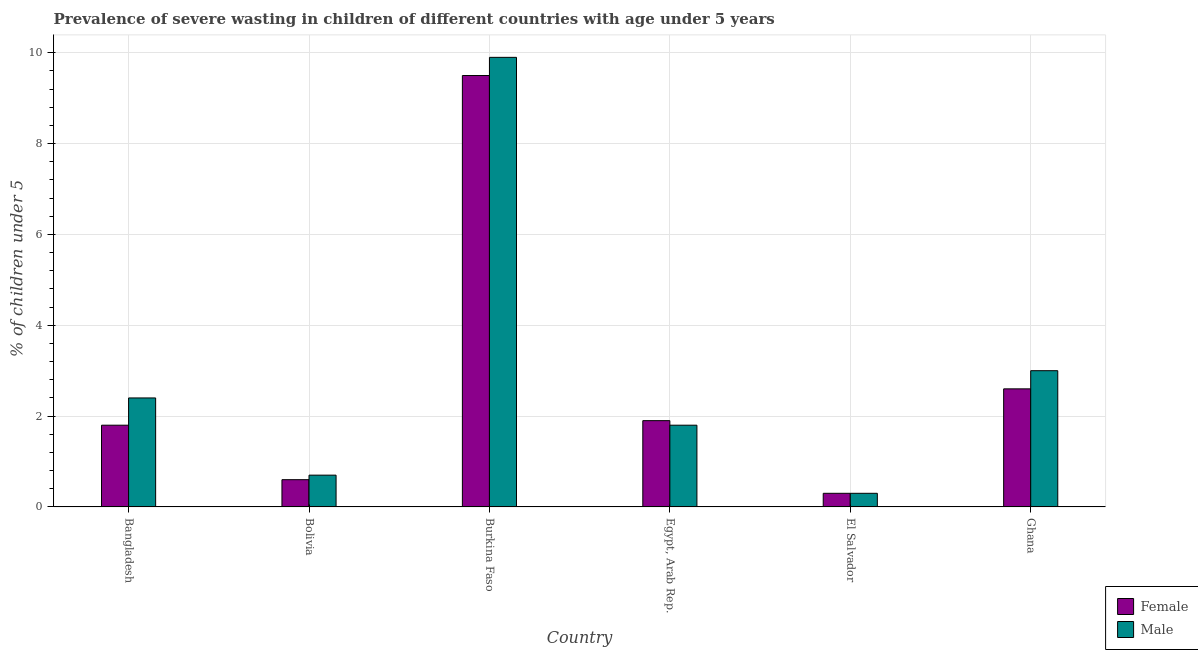How many different coloured bars are there?
Keep it short and to the point. 2. Are the number of bars per tick equal to the number of legend labels?
Your answer should be compact. Yes. How many bars are there on the 3rd tick from the left?
Offer a terse response. 2. How many bars are there on the 1st tick from the right?
Offer a very short reply. 2. What is the label of the 3rd group of bars from the left?
Provide a succinct answer. Burkina Faso. What is the percentage of undernourished female children in El Salvador?
Your response must be concise. 0.3. Across all countries, what is the maximum percentage of undernourished female children?
Keep it short and to the point. 9.5. Across all countries, what is the minimum percentage of undernourished male children?
Your response must be concise. 0.3. In which country was the percentage of undernourished male children maximum?
Keep it short and to the point. Burkina Faso. In which country was the percentage of undernourished male children minimum?
Keep it short and to the point. El Salvador. What is the total percentage of undernourished male children in the graph?
Provide a short and direct response. 18.1. What is the difference between the percentage of undernourished male children in Egypt, Arab Rep. and that in El Salvador?
Your answer should be compact. 1.5. What is the difference between the percentage of undernourished female children in Bangladesh and the percentage of undernourished male children in Bolivia?
Provide a succinct answer. 1.1. What is the average percentage of undernourished male children per country?
Offer a very short reply. 3.02. What is the difference between the percentage of undernourished male children and percentage of undernourished female children in Bangladesh?
Your response must be concise. 0.6. In how many countries, is the percentage of undernourished female children greater than 6.4 %?
Give a very brief answer. 1. What is the ratio of the percentage of undernourished male children in El Salvador to that in Ghana?
Give a very brief answer. 0.1. Is the percentage of undernourished female children in Burkina Faso less than that in Ghana?
Provide a short and direct response. No. Is the difference between the percentage of undernourished male children in El Salvador and Ghana greater than the difference between the percentage of undernourished female children in El Salvador and Ghana?
Your answer should be very brief. No. What is the difference between the highest and the second highest percentage of undernourished female children?
Your answer should be very brief. 6.9. What is the difference between the highest and the lowest percentage of undernourished female children?
Your answer should be very brief. 9.2. What does the 2nd bar from the right in Egypt, Arab Rep. represents?
Offer a very short reply. Female. How many bars are there?
Offer a very short reply. 12. Are all the bars in the graph horizontal?
Offer a very short reply. No. How many countries are there in the graph?
Your answer should be compact. 6. What is the difference between two consecutive major ticks on the Y-axis?
Your answer should be compact. 2. Does the graph contain grids?
Provide a short and direct response. Yes. How many legend labels are there?
Your answer should be very brief. 2. How are the legend labels stacked?
Your response must be concise. Vertical. What is the title of the graph?
Provide a short and direct response. Prevalence of severe wasting in children of different countries with age under 5 years. What is the label or title of the Y-axis?
Provide a succinct answer.  % of children under 5. What is the  % of children under 5 of Female in Bangladesh?
Keep it short and to the point. 1.8. What is the  % of children under 5 of Male in Bangladesh?
Offer a terse response. 2.4. What is the  % of children under 5 in Female in Bolivia?
Give a very brief answer. 0.6. What is the  % of children under 5 in Male in Bolivia?
Offer a terse response. 0.7. What is the  % of children under 5 of Female in Burkina Faso?
Your answer should be very brief. 9.5. What is the  % of children under 5 in Male in Burkina Faso?
Your answer should be very brief. 9.9. What is the  % of children under 5 of Female in Egypt, Arab Rep.?
Offer a very short reply. 1.9. What is the  % of children under 5 in Male in Egypt, Arab Rep.?
Offer a very short reply. 1.8. What is the  % of children under 5 in Female in El Salvador?
Offer a very short reply. 0.3. What is the  % of children under 5 of Male in El Salvador?
Offer a terse response. 0.3. What is the  % of children under 5 of Female in Ghana?
Give a very brief answer. 2.6. Across all countries, what is the maximum  % of children under 5 in Male?
Give a very brief answer. 9.9. Across all countries, what is the minimum  % of children under 5 of Female?
Offer a very short reply. 0.3. Across all countries, what is the minimum  % of children under 5 of Male?
Make the answer very short. 0.3. What is the total  % of children under 5 of Male in the graph?
Your response must be concise. 18.1. What is the difference between the  % of children under 5 of Male in Bangladesh and that in Bolivia?
Give a very brief answer. 1.7. What is the difference between the  % of children under 5 of Female in Bangladesh and that in Burkina Faso?
Your answer should be compact. -7.7. What is the difference between the  % of children under 5 in Male in Bangladesh and that in Ghana?
Ensure brevity in your answer.  -0.6. What is the difference between the  % of children under 5 in Female in Bolivia and that in Burkina Faso?
Provide a short and direct response. -8.9. What is the difference between the  % of children under 5 of Male in Bolivia and that in Egypt, Arab Rep.?
Your answer should be compact. -1.1. What is the difference between the  % of children under 5 in Male in Bolivia and that in El Salvador?
Ensure brevity in your answer.  0.4. What is the difference between the  % of children under 5 in Female in Burkina Faso and that in Egypt, Arab Rep.?
Your answer should be compact. 7.6. What is the difference between the  % of children under 5 of Female in Burkina Faso and that in El Salvador?
Provide a succinct answer. 9.2. What is the difference between the  % of children under 5 of Female in Burkina Faso and that in Ghana?
Your response must be concise. 6.9. What is the difference between the  % of children under 5 in Male in Burkina Faso and that in Ghana?
Provide a succinct answer. 6.9. What is the difference between the  % of children under 5 of Female in Egypt, Arab Rep. and that in Ghana?
Provide a short and direct response. -0.7. What is the difference between the  % of children under 5 of Female in El Salvador and that in Ghana?
Ensure brevity in your answer.  -2.3. What is the difference between the  % of children under 5 in Female in Bangladesh and the  % of children under 5 in Male in Bolivia?
Provide a short and direct response. 1.1. What is the difference between the  % of children under 5 of Female in Bangladesh and the  % of children under 5 of Male in Burkina Faso?
Your answer should be very brief. -8.1. What is the difference between the  % of children under 5 of Female in Bolivia and the  % of children under 5 of Male in Burkina Faso?
Your response must be concise. -9.3. What is the difference between the  % of children under 5 in Female in Bolivia and the  % of children under 5 in Male in Ghana?
Offer a very short reply. -2.4. What is the difference between the  % of children under 5 of Female in Burkina Faso and the  % of children under 5 of Male in Ghana?
Provide a succinct answer. 6.5. What is the difference between the  % of children under 5 of Female in Egypt, Arab Rep. and the  % of children under 5 of Male in El Salvador?
Provide a succinct answer. 1.6. What is the difference between the  % of children under 5 in Female in Egypt, Arab Rep. and the  % of children under 5 in Male in Ghana?
Provide a short and direct response. -1.1. What is the difference between the  % of children under 5 of Female in El Salvador and the  % of children under 5 of Male in Ghana?
Your response must be concise. -2.7. What is the average  % of children under 5 in Female per country?
Your response must be concise. 2.78. What is the average  % of children under 5 in Male per country?
Offer a terse response. 3.02. What is the difference between the  % of children under 5 of Female and  % of children under 5 of Male in Bolivia?
Provide a short and direct response. -0.1. What is the difference between the  % of children under 5 of Female and  % of children under 5 of Male in Egypt, Arab Rep.?
Keep it short and to the point. 0.1. What is the ratio of the  % of children under 5 in Female in Bangladesh to that in Bolivia?
Your response must be concise. 3. What is the ratio of the  % of children under 5 in Male in Bangladesh to that in Bolivia?
Provide a short and direct response. 3.43. What is the ratio of the  % of children under 5 of Female in Bangladesh to that in Burkina Faso?
Provide a short and direct response. 0.19. What is the ratio of the  % of children under 5 of Male in Bangladesh to that in Burkina Faso?
Offer a terse response. 0.24. What is the ratio of the  % of children under 5 in Female in Bangladesh to that in Egypt, Arab Rep.?
Offer a terse response. 0.95. What is the ratio of the  % of children under 5 of Male in Bangladesh to that in Egypt, Arab Rep.?
Your response must be concise. 1.33. What is the ratio of the  % of children under 5 in Female in Bangladesh to that in El Salvador?
Your answer should be very brief. 6. What is the ratio of the  % of children under 5 in Male in Bangladesh to that in El Salvador?
Provide a short and direct response. 8. What is the ratio of the  % of children under 5 of Female in Bangladesh to that in Ghana?
Give a very brief answer. 0.69. What is the ratio of the  % of children under 5 of Male in Bangladesh to that in Ghana?
Make the answer very short. 0.8. What is the ratio of the  % of children under 5 in Female in Bolivia to that in Burkina Faso?
Provide a succinct answer. 0.06. What is the ratio of the  % of children under 5 of Male in Bolivia to that in Burkina Faso?
Provide a succinct answer. 0.07. What is the ratio of the  % of children under 5 of Female in Bolivia to that in Egypt, Arab Rep.?
Keep it short and to the point. 0.32. What is the ratio of the  % of children under 5 of Male in Bolivia to that in Egypt, Arab Rep.?
Your answer should be very brief. 0.39. What is the ratio of the  % of children under 5 in Male in Bolivia to that in El Salvador?
Offer a terse response. 2.33. What is the ratio of the  % of children under 5 in Female in Bolivia to that in Ghana?
Your answer should be compact. 0.23. What is the ratio of the  % of children under 5 in Male in Bolivia to that in Ghana?
Make the answer very short. 0.23. What is the ratio of the  % of children under 5 in Female in Burkina Faso to that in Egypt, Arab Rep.?
Make the answer very short. 5. What is the ratio of the  % of children under 5 of Male in Burkina Faso to that in Egypt, Arab Rep.?
Offer a terse response. 5.5. What is the ratio of the  % of children under 5 of Female in Burkina Faso to that in El Salvador?
Keep it short and to the point. 31.67. What is the ratio of the  % of children under 5 in Male in Burkina Faso to that in El Salvador?
Offer a very short reply. 33. What is the ratio of the  % of children under 5 of Female in Burkina Faso to that in Ghana?
Give a very brief answer. 3.65. What is the ratio of the  % of children under 5 in Female in Egypt, Arab Rep. to that in El Salvador?
Your answer should be compact. 6.33. What is the ratio of the  % of children under 5 in Male in Egypt, Arab Rep. to that in El Salvador?
Your answer should be compact. 6. What is the ratio of the  % of children under 5 in Female in Egypt, Arab Rep. to that in Ghana?
Your answer should be very brief. 0.73. What is the ratio of the  % of children under 5 in Male in Egypt, Arab Rep. to that in Ghana?
Keep it short and to the point. 0.6. What is the ratio of the  % of children under 5 of Female in El Salvador to that in Ghana?
Make the answer very short. 0.12. What is the difference between the highest and the second highest  % of children under 5 in Female?
Ensure brevity in your answer.  6.9. What is the difference between the highest and the second highest  % of children under 5 of Male?
Give a very brief answer. 6.9. What is the difference between the highest and the lowest  % of children under 5 in Female?
Ensure brevity in your answer.  9.2. 